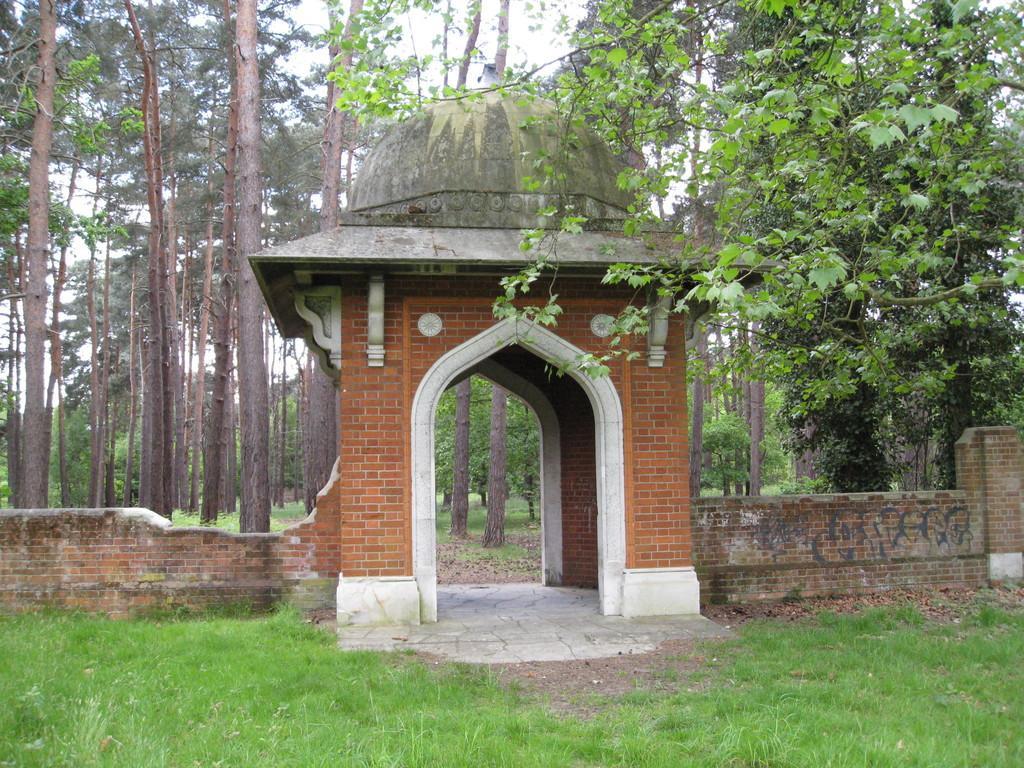Describe this image in one or two sentences. In the middle of the picture, we see an arch. Beside that, we see a wall which is made up of bricks. At the bottom, we see the grass. There are trees in the background. 